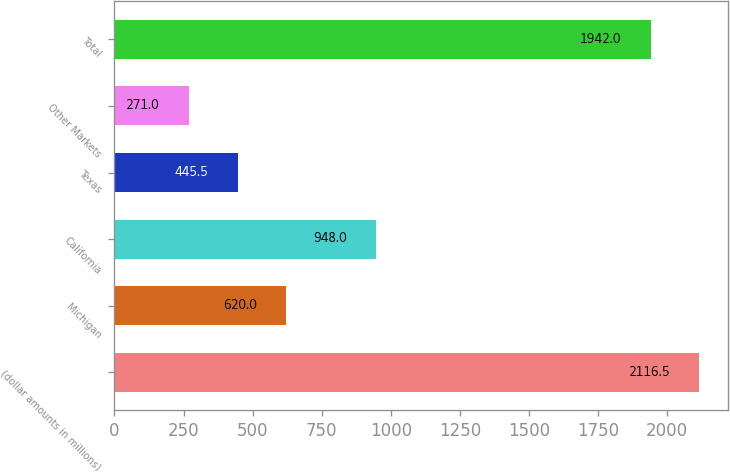Convert chart to OTSL. <chart><loc_0><loc_0><loc_500><loc_500><bar_chart><fcel>(dollar amounts in millions)<fcel>Michigan<fcel>California<fcel>Texas<fcel>Other Markets<fcel>Total<nl><fcel>2116.5<fcel>620<fcel>948<fcel>445.5<fcel>271<fcel>1942<nl></chart> 